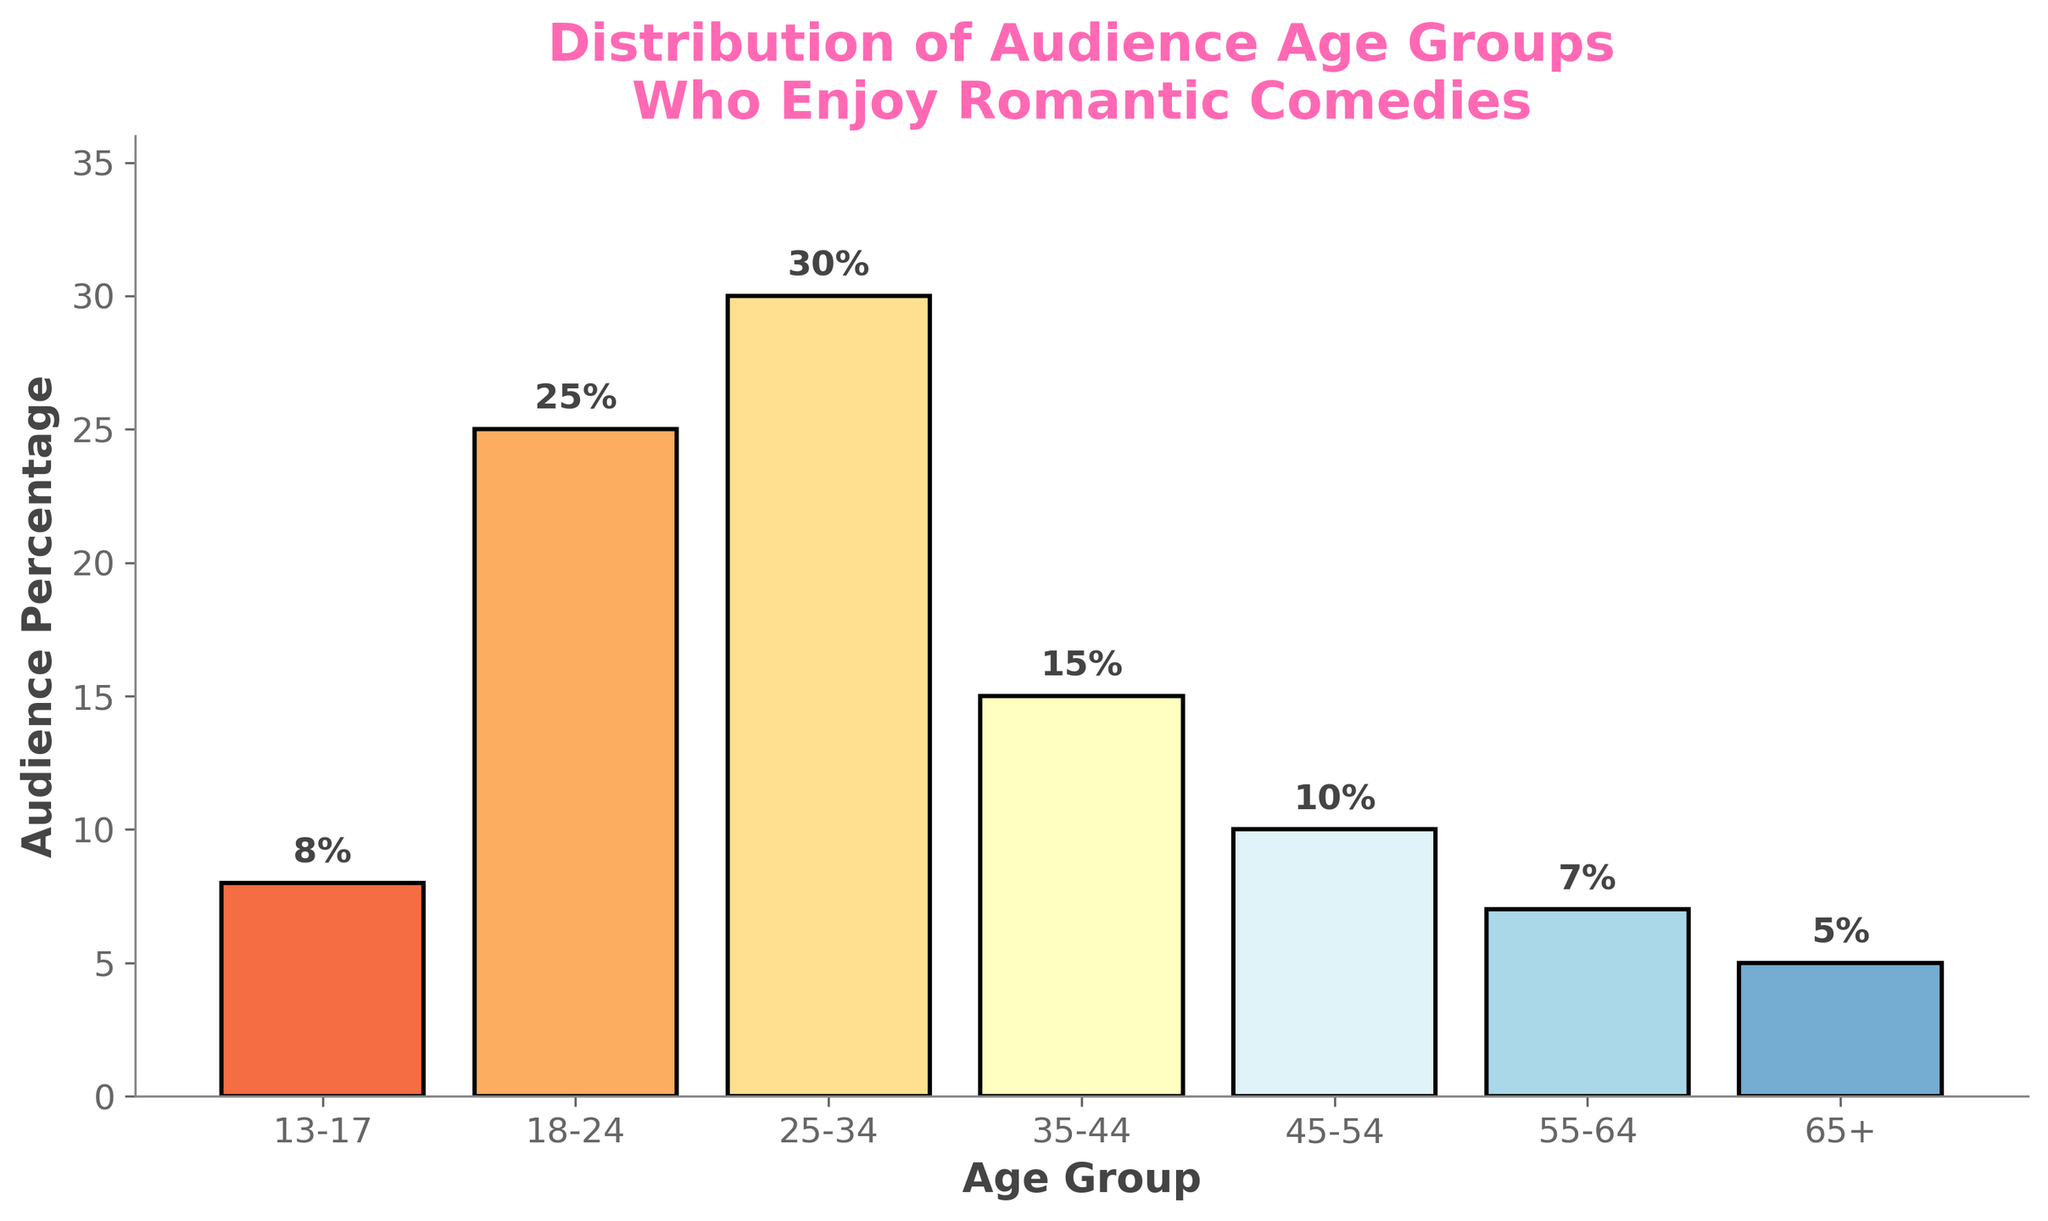What is the title of the figure? The title of the figure is centered at the top and gives an overview of the content of the plot. It reads "Distribution of Audience Age Groups Who Enjoy Romantic Comedies".
Answer: Distribution of Audience Age Groups Who Enjoy Romantic Comedies Which age group has the highest audience percentage? Looking at the bars and their labels, the tallest bar represents the 25-34 age group at 30%.
Answer: 25-34 What is the audience percentage for the age group 18-24? The second bar from the left, labeled 18-24, reaches up to 25%. Thus, the percentage is 25%.
Answer: 25% What is the difference in audience percentages between the 25-34 and 65+ age groups? The 25-34 age group has 30%, and the 65+ age group has 5%. Subtracting 5 from 30 gives us 25.
Answer: 25% Which age group has the lowest audience percentage and what is it? The shortest bar represents the 65+ age group, which stands at 5%.
Answer: 65+, 5% How many age groups have an audience percentage of 10% or higher? The age groups can be visually checked: 13-17, 18-24, 25-34, 35-44, and 45-54 have audience percentages of 10% or higher, totaling five groups.
Answer: Five Calculate the average audience percentage of all age groups. Sum all the percentages: 8 + 25 + 30 + 15 + 10 + 7 + 5 = 100. There are 7 age groups, so the average is 100 / 7 ≈ 14.29%.
Answer: 14.29% How does the audience percentage of the 35-44 age group compare to that of the 45-54 age group? The percentage for 35-44 is 15%, while for 45-54, it is 10%. Therefore, the 35-44 age group has a 5% higher audience percentage.
Answer: 5% higher What percentage more/less does the 13-17 age group have compared to the 55-64 age group? The 13-17 age group has 8%, and the 55-64 age group has 7%. The difference is 8% - 7% = 1%, meaning the 13-17 group has 1% more.
Answer: 1% more 